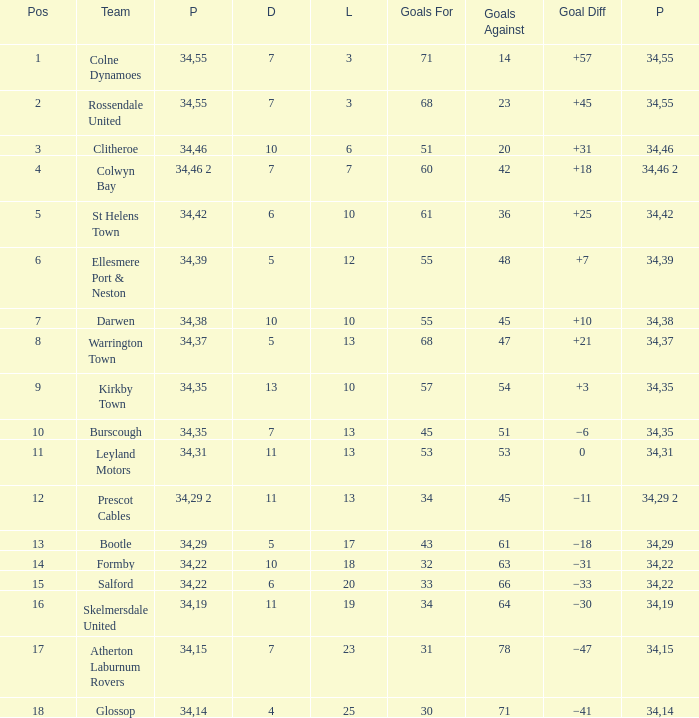How many Drawn have a Lost smaller than 25, and a Goal Difference of +7, and a Played larger than 34? 0.0. 